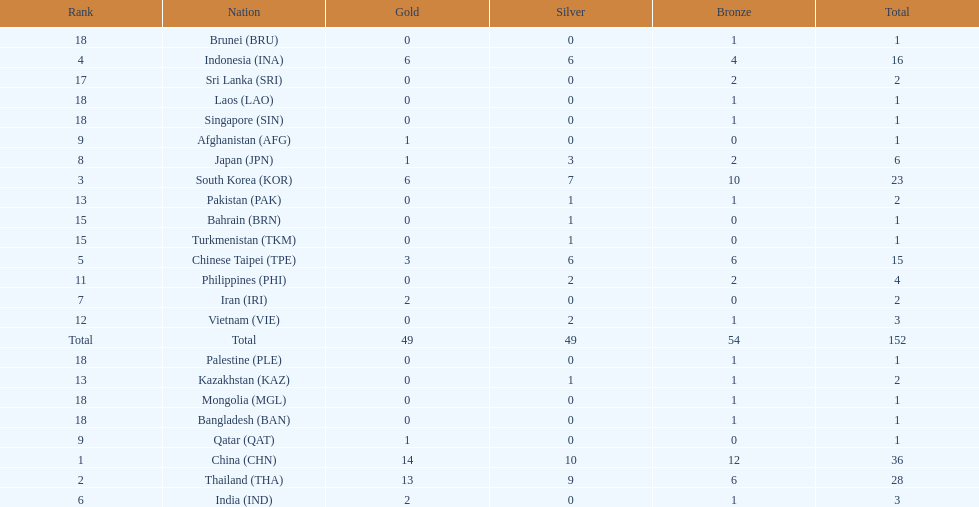What is the total number of nations that participated in the beach games of 2012? 23. 